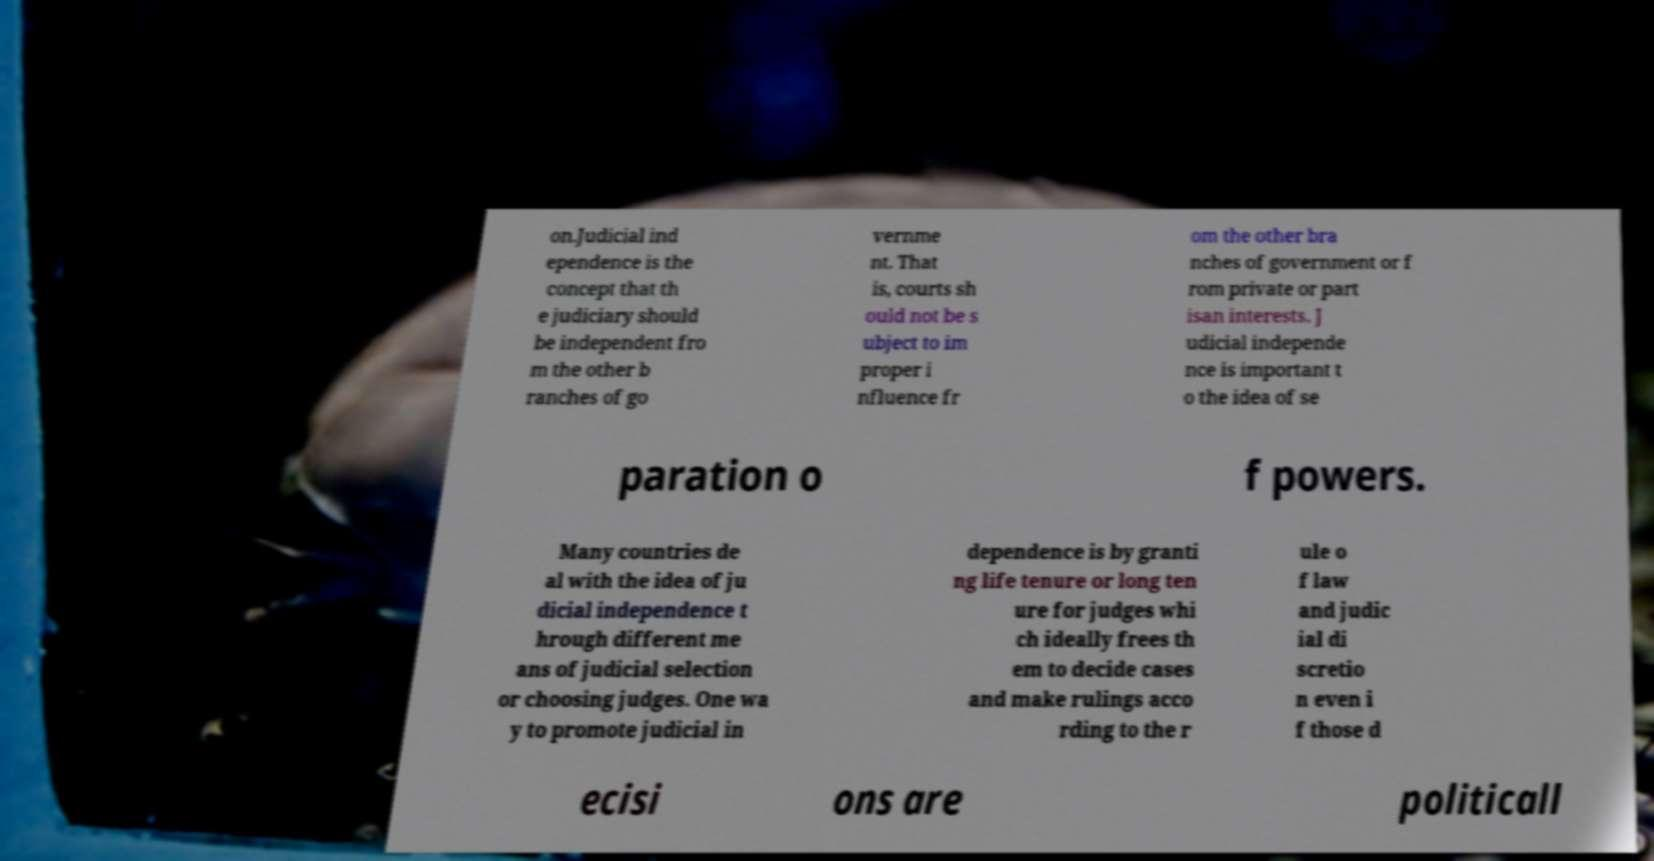Could you extract and type out the text from this image? on.Judicial ind ependence is the concept that th e judiciary should be independent fro m the other b ranches of go vernme nt. That is, courts sh ould not be s ubject to im proper i nfluence fr om the other bra nches of government or f rom private or part isan interests. J udicial independe nce is important t o the idea of se paration o f powers. Many countries de al with the idea of ju dicial independence t hrough different me ans of judicial selection or choosing judges. One wa y to promote judicial in dependence is by granti ng life tenure or long ten ure for judges whi ch ideally frees th em to decide cases and make rulings acco rding to the r ule o f law and judic ial di scretio n even i f those d ecisi ons are politicall 